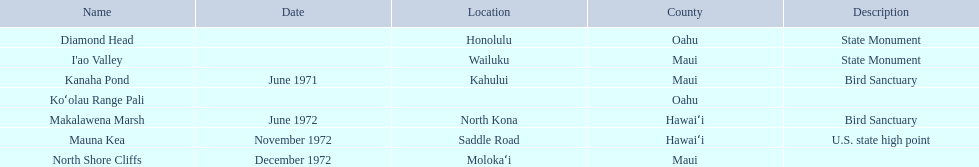What are the national natural landmarks in hawaii? Diamond Head, I'ao Valley, Kanaha Pond, Koʻolau Range Pali, Makalawena Marsh, Mauna Kea, North Shore Cliffs. Which of theses are in hawa'i county? Makalawena Marsh, Mauna Kea. Of these which has a bird sanctuary? Makalawena Marsh. 